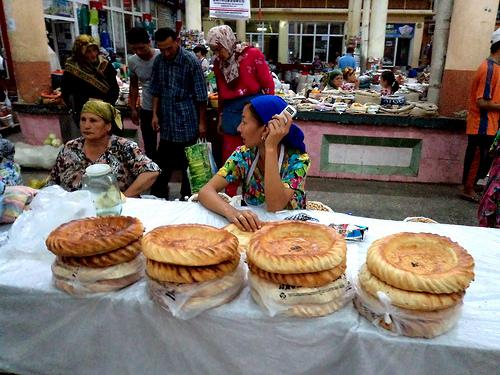Question: what is blue?
Choices:
A. Headdress.
B. Sky.
C. Feather of a bird.
D. Tablecloth.
Answer with the letter. Answer: A Question: who is sitting?
Choices:
A. We are.
B. He is.
C. Two ladies.
D. They are.
Answer with the letter. Answer: C Question: why are they sitting?
Choices:
A. They are tired.
B. Selling the cakes.
C. They are slow.
D. They want to.
Answer with the letter. Answer: B Question: what is silver?
Choices:
A. Phone.
B. A spoon.
C. A fork.
D. A knife.
Answer with the letter. Answer: A Question: where are they sitting?
Choices:
A. A chair.
B. The ground.
C. Table.
D. A stool.
Answer with the letter. Answer: C Question: how many stacks of cake?
Choices:
A. Four.
B. One.
C. Two.
D. Three.
Answer with the letter. Answer: A 